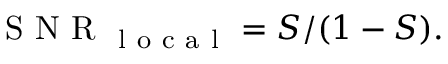Convert formula to latex. <formula><loc_0><loc_0><loc_500><loc_500>S N R _ { l o c a l } = S / ( 1 - S ) .</formula> 